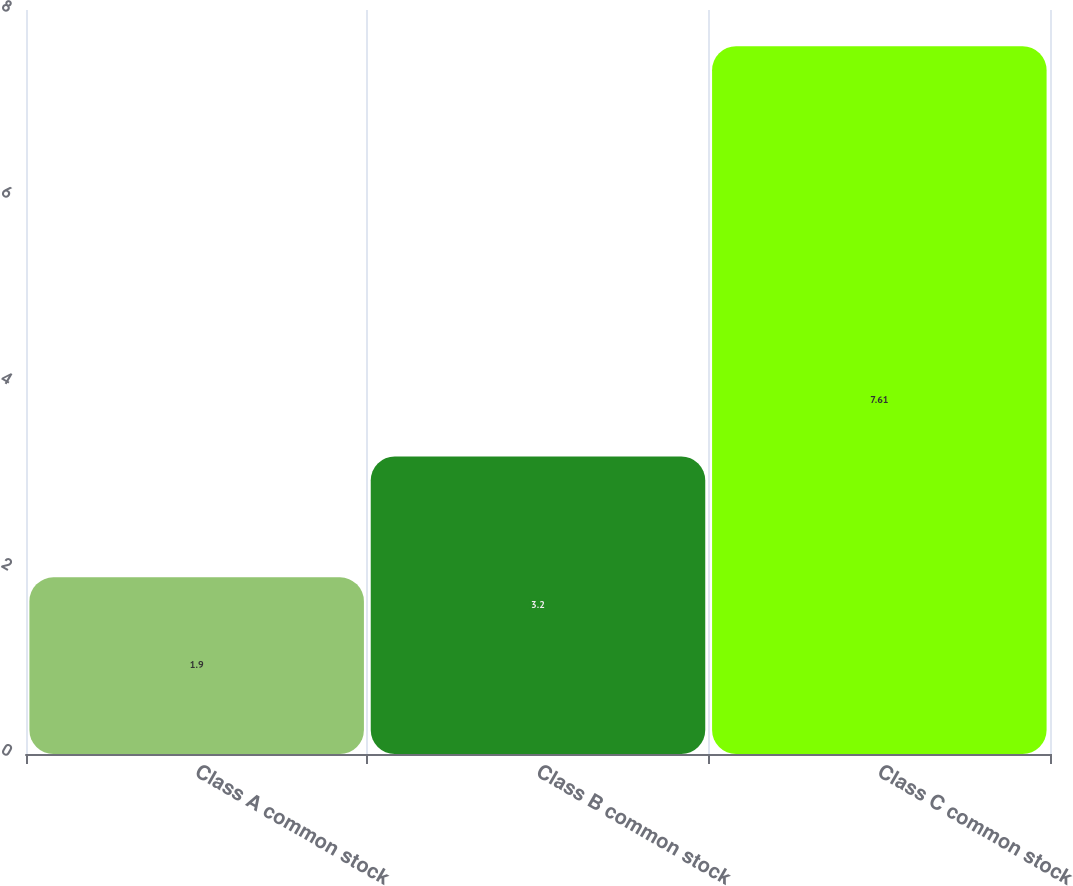<chart> <loc_0><loc_0><loc_500><loc_500><bar_chart><fcel>Class A common stock<fcel>Class B common stock<fcel>Class C common stock<nl><fcel>1.9<fcel>3.2<fcel>7.61<nl></chart> 